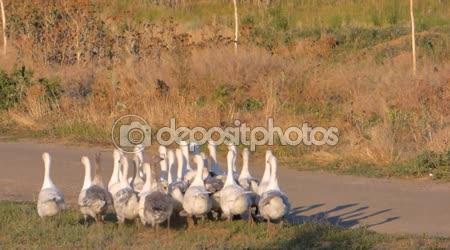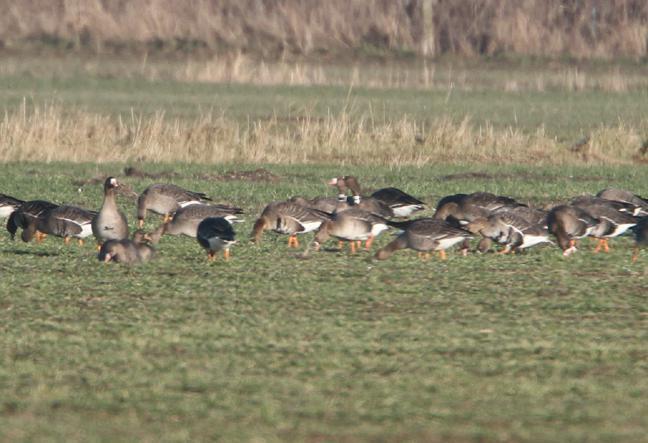The first image is the image on the left, the second image is the image on the right. Considering the images on both sides, is "One of the images in the pair shows a flock of canada geese." valid? Answer yes or no. No. 